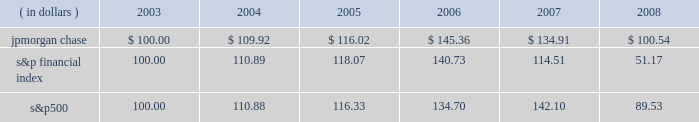Management 2019s discussion and analysis jpmorgan chase & co .
/ 2008 annual report 39 five-year stock performance the table and graph compare the five-year cumulative total return for jpmorgan chase & co .
( 201cjpmorgan chase 201d or the 201cfirm 201d ) common stock with the cumulative return of the s&p 500 stock index and the s&p financial index .
The s&p 500 index is a commonly referenced u.s .
Equity benchmark consisting of leading companies from different economic sectors .
The s&p financial index is an index of 81 financial companies , all of which are within the s&p 500 .
The firm is a component of both industry indices .
The table and graph assumes simultaneous investments of $ 100 on december 31 , 2003 , in jpmorgan chase common stock and in each of the above s&p indices .
The comparison assumes that all dividends are reinvested .
This section of the jpmorgan chase 2019s annual report for the year ended december 31 , 2008 ( 201cannual report 201d ) provides manage- ment 2019s discussion and analysis of the financial condition and results of operations ( 201cmd&a 201d ) of jpmorgan chase .
See the glossary of terms on pages 230 2013233 for definitions of terms used throughout this annual report .
The md&a included in this annual report con- tains statements that are forward-looking within the meaning of the private securities litigation reform act of 1995 .
Such statements are based upon the current beliefs and expectations of jpmorgan december 31 .
December 31 , ( in dollars ) 2003 2004 2005 2006 2007 2008 s&p financial s&p 500jpmorgan chase chase 2019s management and are subject to significant risks and uncer- tainties .
These risks and uncertainties could cause jpmorgan chase 2019s results to differ materially from those set forth in such forward-look- ing statements .
Certain of such risks and uncertainties are described herein ( see forward-looking statements on page 127 of this annual report ) and in the jpmorgan chase annual report on form 10-k for the year ended december 31 , 2008 ( 201c2008 form 10-k 201d ) , in part i , item 1a : risk factors , to which reference is hereby made .
Introduction jpmorgan chase & co. , a financial holding company incorporated under delaware law in 1968 , is a leading global financial services firm and one of the largest banking institutions in the united states of america ( 201cu.s . 201d ) , with $ 2.2 trillion in assets , $ 166.9 billion in stockholders 2019 equity and operations in more than 60 countries as of december 31 , 2008 .
The firm is a leader in investment banking , financial services for consumers and businesses , financial transaction processing and asset management .
Under the j.p .
Morgan and chase brands , the firm serves millions of customers in the u.s .
And many of the world 2019s most prominent corporate , institutional and government clients .
Jpmorgan chase 2019s principal bank subsidiaries are jpmorgan chase bank , national association ( 201cjpmorgan chase bank , n.a . 201d ) , a nation- al banking association with branches in 23 states in the u.s. ; and chase bank usa , national association ( 201cchase bank usa , n.a . 201d ) , a national bank that is the firm 2019s credit card issuing bank .
Jpmorgan chase 2019s principal nonbank subsidiary is j.p .
Morgan securities inc. , the firm 2019s u.s .
Investment banking firm .
Jpmorgan chase 2019s activities are organized , for management reporting purposes , into six business segments , as well as corporate/private equity .
The firm 2019s wholesale businesses comprise the investment bank , commercial banking , treasury & securities services and asset management segments .
The firm 2019s consumer businesses comprise the retail financial services and card services segments .
A description of the firm 2019s business segments , and the products and services they pro- vide to their respective client bases , follows .
Investment bank j.p .
Morgan is one of the world 2019s leading investment banks , with deep client relationships and broad product capabilities .
The investment bank 2019s clients are corporations , financial institutions , governments and institutional investors .
The firm offers a full range of investment banking products and services in all major capital markets , including advising on corporate strategy and structure , cap- ital raising in equity and debt markets , sophisticated risk manage- ment , market-making in cash securities and derivative instruments , prime brokerage and research .
The investment bank ( 201cib 201d ) also selectively commits the firm 2019s own capital to principal investing and trading activities .
Retail financial services retail financial services ( 201crfs 201d ) , which includes the retail banking and consumer lending reporting segments , serves consumers and businesses through personal service at bank branches and through atms , online banking and telephone banking as well as through auto dealerships and school financial aid offices .
Customers can use more than 5400 bank branches ( third-largest nationally ) and 14500 atms ( second-largest nationally ) as well as online and mobile bank- ing around the clock .
More than 21400 branch salespeople assist .
What was the ratio of the assets to stockholders equity in 2008? 
Rationale: 2 jpmorgan chase $ 100.00 $ 109.92 $ 116.02 $ 145.36 $ 134.91 $ 100.54\\n3 s&p financial index 100.00 110.89 118.07 140.73 114.51 51.17
Computations: (2.2 / 166.9)
Answer: 0.01318. 